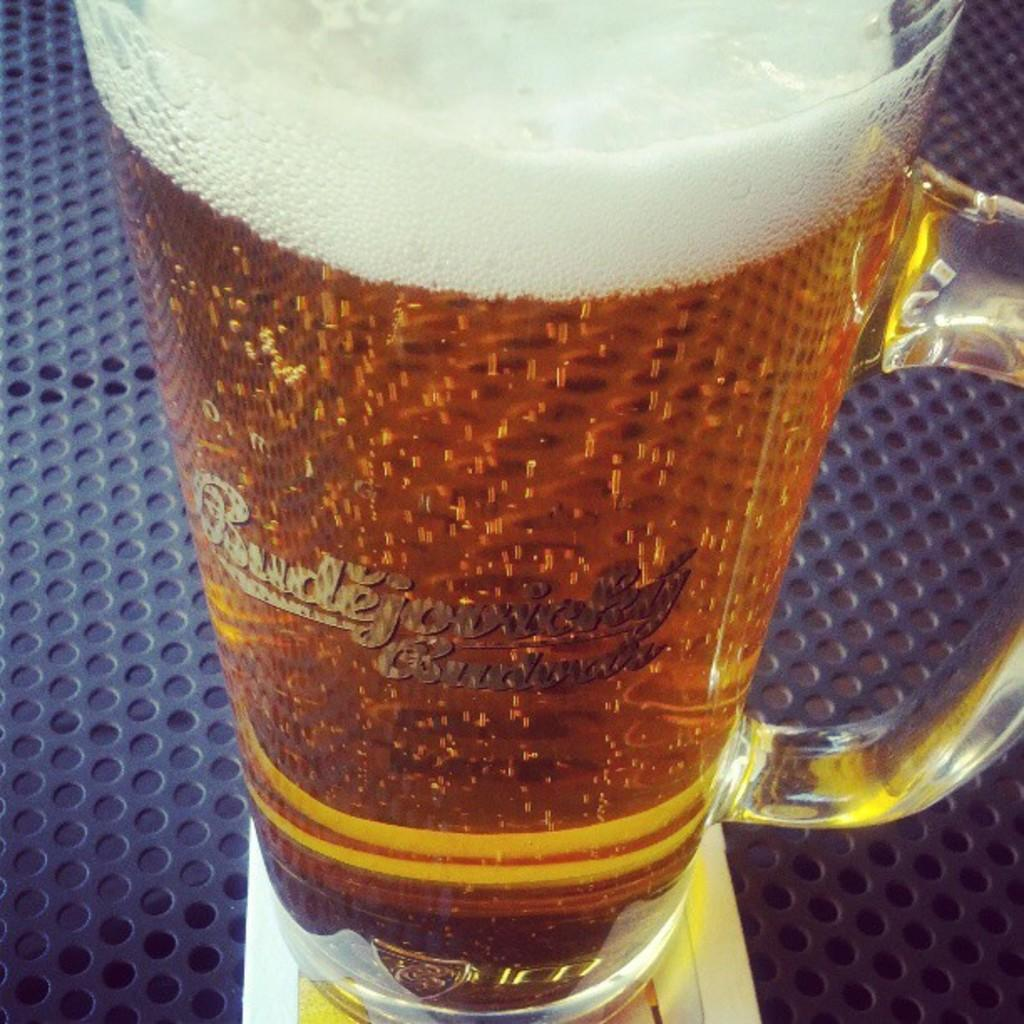<image>
Render a clear and concise summary of the photo. Beer in a glass with gold lettering of Budejovickly 